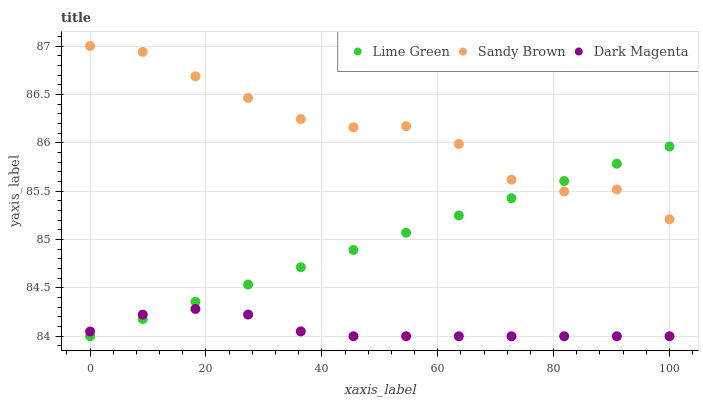Does Dark Magenta have the minimum area under the curve?
Answer yes or no. Yes. Does Sandy Brown have the maximum area under the curve?
Answer yes or no. Yes. Does Lime Green have the minimum area under the curve?
Answer yes or no. No. Does Lime Green have the maximum area under the curve?
Answer yes or no. No. Is Lime Green the smoothest?
Answer yes or no. Yes. Is Sandy Brown the roughest?
Answer yes or no. Yes. Is Dark Magenta the smoothest?
Answer yes or no. No. Is Dark Magenta the roughest?
Answer yes or no. No. Does Lime Green have the lowest value?
Answer yes or no. Yes. Does Sandy Brown have the highest value?
Answer yes or no. Yes. Does Lime Green have the highest value?
Answer yes or no. No. Is Dark Magenta less than Sandy Brown?
Answer yes or no. Yes. Is Sandy Brown greater than Dark Magenta?
Answer yes or no. Yes. Does Lime Green intersect Dark Magenta?
Answer yes or no. Yes. Is Lime Green less than Dark Magenta?
Answer yes or no. No. Is Lime Green greater than Dark Magenta?
Answer yes or no. No. Does Dark Magenta intersect Sandy Brown?
Answer yes or no. No. 